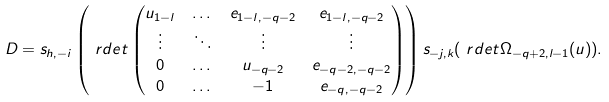<formula> <loc_0><loc_0><loc_500><loc_500>D & = s _ { h , - i } \left ( \ r d e t \begin{pmatrix} u _ { 1 - l } & \dots & e _ { 1 - l , - q - 2 } & e _ { 1 - l , - q - 2 } \\ \vdots & \ddots & \vdots & \vdots \\ 0 & \dots & u _ { - q - 2 } & e _ { - q - 2 , - q - 2 } \\ 0 & \dots & - 1 & e _ { - q , - q - 2 } \end{pmatrix} \right ) s _ { - j , k } ( \ r d e t \Omega _ { - q + 2 , l - 1 } ( u ) ) .</formula> 